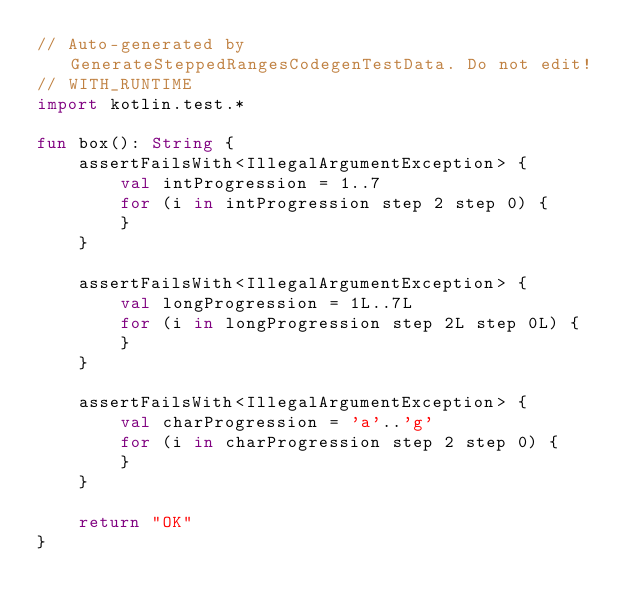Convert code to text. <code><loc_0><loc_0><loc_500><loc_500><_Kotlin_>// Auto-generated by GenerateSteppedRangesCodegenTestData. Do not edit!
// WITH_RUNTIME
import kotlin.test.*

fun box(): String {
    assertFailsWith<IllegalArgumentException> {
        val intProgression = 1..7
        for (i in intProgression step 2 step 0) {
        }
    }

    assertFailsWith<IllegalArgumentException> {
        val longProgression = 1L..7L
        for (i in longProgression step 2L step 0L) {
        }
    }

    assertFailsWith<IllegalArgumentException> {
        val charProgression = 'a'..'g'
        for (i in charProgression step 2 step 0) {
        }
    }

    return "OK"
}</code> 